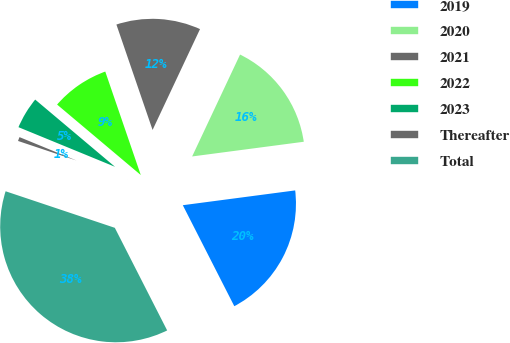Convert chart. <chart><loc_0><loc_0><loc_500><loc_500><pie_chart><fcel>2019<fcel>2020<fcel>2021<fcel>2022<fcel>2023<fcel>Thereafter<fcel>Total<nl><fcel>19.58%<fcel>15.92%<fcel>12.26%<fcel>8.6%<fcel>4.94%<fcel>1.06%<fcel>37.65%<nl></chart> 